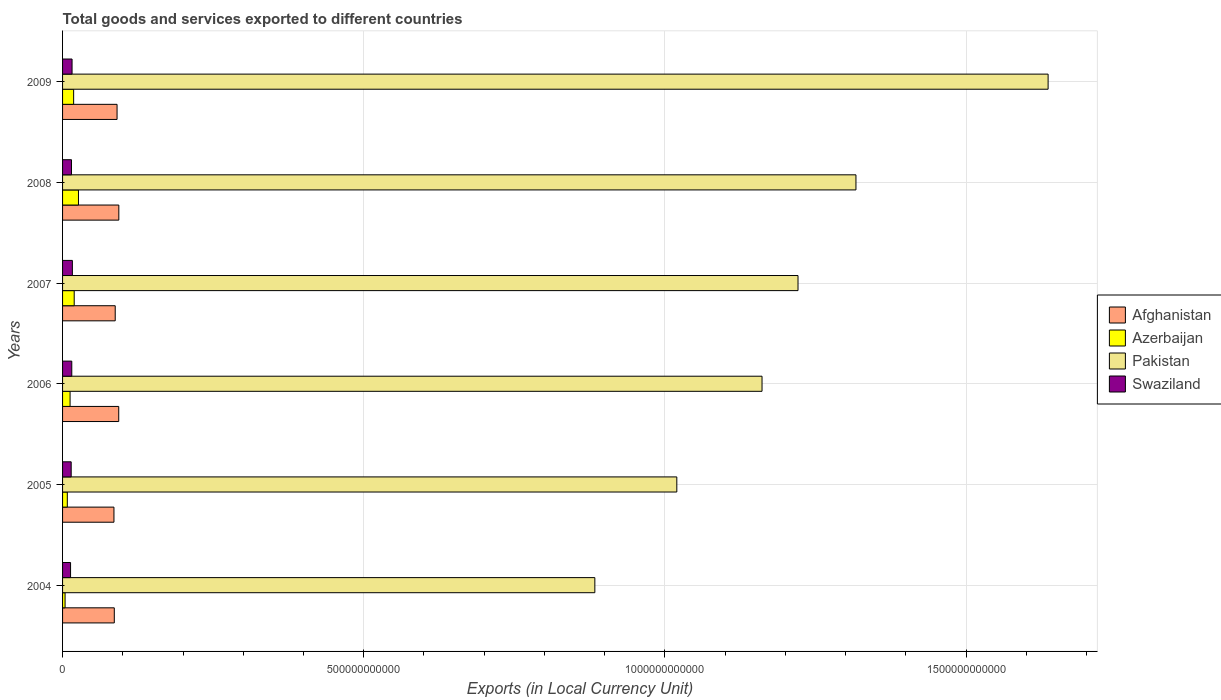What is the label of the 5th group of bars from the top?
Make the answer very short. 2005. What is the Amount of goods and services exports in Swaziland in 2008?
Offer a terse response. 1.48e+1. Across all years, what is the maximum Amount of goods and services exports in Afghanistan?
Offer a very short reply. 9.34e+1. Across all years, what is the minimum Amount of goods and services exports in Afghanistan?
Offer a terse response. 8.53e+1. In which year was the Amount of goods and services exports in Pakistan minimum?
Provide a short and direct response. 2004. What is the total Amount of goods and services exports in Pakistan in the graph?
Provide a short and direct response. 7.24e+12. What is the difference between the Amount of goods and services exports in Swaziland in 2004 and that in 2007?
Offer a very short reply. -3.00e+09. What is the difference between the Amount of goods and services exports in Azerbaijan in 2006 and the Amount of goods and services exports in Pakistan in 2009?
Your answer should be compact. -1.62e+12. What is the average Amount of goods and services exports in Pakistan per year?
Make the answer very short. 1.21e+12. In the year 2008, what is the difference between the Amount of goods and services exports in Azerbaijan and Amount of goods and services exports in Pakistan?
Make the answer very short. -1.29e+12. In how many years, is the Amount of goods and services exports in Pakistan greater than 1600000000000 LCU?
Offer a very short reply. 1. What is the ratio of the Amount of goods and services exports in Swaziland in 2007 to that in 2008?
Offer a terse response. 1.1. Is the Amount of goods and services exports in Pakistan in 2005 less than that in 2006?
Keep it short and to the point. Yes. What is the difference between the highest and the second highest Amount of goods and services exports in Swaziland?
Your response must be concise. 5.19e+08. What is the difference between the highest and the lowest Amount of goods and services exports in Swaziland?
Keep it short and to the point. 3.00e+09. In how many years, is the Amount of goods and services exports in Swaziland greater than the average Amount of goods and services exports in Swaziland taken over all years?
Provide a short and direct response. 3. Is it the case that in every year, the sum of the Amount of goods and services exports in Swaziland and Amount of goods and services exports in Azerbaijan is greater than the sum of Amount of goods and services exports in Afghanistan and Amount of goods and services exports in Pakistan?
Your response must be concise. No. What does the 3rd bar from the top in 2005 represents?
Keep it short and to the point. Azerbaijan. What does the 1st bar from the bottom in 2004 represents?
Your answer should be compact. Afghanistan. Is it the case that in every year, the sum of the Amount of goods and services exports in Azerbaijan and Amount of goods and services exports in Afghanistan is greater than the Amount of goods and services exports in Pakistan?
Give a very brief answer. No. Are all the bars in the graph horizontal?
Give a very brief answer. Yes. How many years are there in the graph?
Your answer should be very brief. 6. What is the difference between two consecutive major ticks on the X-axis?
Offer a terse response. 5.00e+11. Where does the legend appear in the graph?
Ensure brevity in your answer.  Center right. What is the title of the graph?
Give a very brief answer. Total goods and services exported to different countries. What is the label or title of the X-axis?
Your answer should be compact. Exports (in Local Currency Unit). What is the Exports (in Local Currency Unit) in Afghanistan in 2004?
Your answer should be compact. 8.59e+1. What is the Exports (in Local Currency Unit) in Azerbaijan in 2004?
Ensure brevity in your answer.  4.16e+09. What is the Exports (in Local Currency Unit) in Pakistan in 2004?
Offer a terse response. 8.84e+11. What is the Exports (in Local Currency Unit) in Swaziland in 2004?
Your answer should be very brief. 1.33e+1. What is the Exports (in Local Currency Unit) in Afghanistan in 2005?
Keep it short and to the point. 8.53e+1. What is the Exports (in Local Currency Unit) in Azerbaijan in 2005?
Make the answer very short. 7.88e+09. What is the Exports (in Local Currency Unit) of Pakistan in 2005?
Provide a succinct answer. 1.02e+12. What is the Exports (in Local Currency Unit) of Swaziland in 2005?
Ensure brevity in your answer.  1.43e+1. What is the Exports (in Local Currency Unit) in Afghanistan in 2006?
Keep it short and to the point. 9.33e+1. What is the Exports (in Local Currency Unit) of Azerbaijan in 2006?
Offer a terse response. 1.25e+1. What is the Exports (in Local Currency Unit) of Pakistan in 2006?
Your answer should be very brief. 1.16e+12. What is the Exports (in Local Currency Unit) of Swaziland in 2006?
Provide a succinct answer. 1.53e+1. What is the Exports (in Local Currency Unit) in Afghanistan in 2007?
Make the answer very short. 8.74e+1. What is the Exports (in Local Currency Unit) of Azerbaijan in 2007?
Give a very brief answer. 1.93e+1. What is the Exports (in Local Currency Unit) in Pakistan in 2007?
Provide a short and direct response. 1.22e+12. What is the Exports (in Local Currency Unit) of Swaziland in 2007?
Offer a terse response. 1.63e+1. What is the Exports (in Local Currency Unit) in Afghanistan in 2008?
Provide a succinct answer. 9.34e+1. What is the Exports (in Local Currency Unit) of Azerbaijan in 2008?
Keep it short and to the point. 2.64e+1. What is the Exports (in Local Currency Unit) in Pakistan in 2008?
Provide a short and direct response. 1.32e+12. What is the Exports (in Local Currency Unit) of Swaziland in 2008?
Provide a succinct answer. 1.48e+1. What is the Exports (in Local Currency Unit) in Afghanistan in 2009?
Give a very brief answer. 9.05e+1. What is the Exports (in Local Currency Unit) in Azerbaijan in 2009?
Give a very brief answer. 1.84e+1. What is the Exports (in Local Currency Unit) of Pakistan in 2009?
Offer a very short reply. 1.64e+12. What is the Exports (in Local Currency Unit) in Swaziland in 2009?
Your answer should be very brief. 1.58e+1. Across all years, what is the maximum Exports (in Local Currency Unit) in Afghanistan?
Offer a terse response. 9.34e+1. Across all years, what is the maximum Exports (in Local Currency Unit) of Azerbaijan?
Your answer should be compact. 2.64e+1. Across all years, what is the maximum Exports (in Local Currency Unit) in Pakistan?
Offer a very short reply. 1.64e+12. Across all years, what is the maximum Exports (in Local Currency Unit) in Swaziland?
Your answer should be very brief. 1.63e+1. Across all years, what is the minimum Exports (in Local Currency Unit) of Afghanistan?
Offer a terse response. 8.53e+1. Across all years, what is the minimum Exports (in Local Currency Unit) in Azerbaijan?
Provide a succinct answer. 4.16e+09. Across all years, what is the minimum Exports (in Local Currency Unit) of Pakistan?
Your response must be concise. 8.84e+11. Across all years, what is the minimum Exports (in Local Currency Unit) of Swaziland?
Give a very brief answer. 1.33e+1. What is the total Exports (in Local Currency Unit) in Afghanistan in the graph?
Your answer should be compact. 5.36e+11. What is the total Exports (in Local Currency Unit) of Azerbaijan in the graph?
Offer a very short reply. 8.86e+1. What is the total Exports (in Local Currency Unit) of Pakistan in the graph?
Provide a short and direct response. 7.24e+12. What is the total Exports (in Local Currency Unit) in Swaziland in the graph?
Your answer should be compact. 8.97e+1. What is the difference between the Exports (in Local Currency Unit) of Afghanistan in 2004 and that in 2005?
Offer a very short reply. 5.55e+08. What is the difference between the Exports (in Local Currency Unit) of Azerbaijan in 2004 and that in 2005?
Your answer should be compact. -3.72e+09. What is the difference between the Exports (in Local Currency Unit) of Pakistan in 2004 and that in 2005?
Your answer should be compact. -1.36e+11. What is the difference between the Exports (in Local Currency Unit) of Swaziland in 2004 and that in 2005?
Offer a terse response. -1.03e+09. What is the difference between the Exports (in Local Currency Unit) of Afghanistan in 2004 and that in 2006?
Provide a succinct answer. -7.38e+09. What is the difference between the Exports (in Local Currency Unit) of Azerbaijan in 2004 and that in 2006?
Your response must be concise. -8.31e+09. What is the difference between the Exports (in Local Currency Unit) in Pakistan in 2004 and that in 2006?
Your answer should be very brief. -2.78e+11. What is the difference between the Exports (in Local Currency Unit) of Swaziland in 2004 and that in 2006?
Make the answer very short. -2.01e+09. What is the difference between the Exports (in Local Currency Unit) in Afghanistan in 2004 and that in 2007?
Your response must be concise. -1.53e+09. What is the difference between the Exports (in Local Currency Unit) of Azerbaijan in 2004 and that in 2007?
Ensure brevity in your answer.  -1.52e+1. What is the difference between the Exports (in Local Currency Unit) of Pakistan in 2004 and that in 2007?
Your answer should be very brief. -3.37e+11. What is the difference between the Exports (in Local Currency Unit) in Swaziland in 2004 and that in 2007?
Your answer should be very brief. -3.00e+09. What is the difference between the Exports (in Local Currency Unit) of Afghanistan in 2004 and that in 2008?
Make the answer very short. -7.54e+09. What is the difference between the Exports (in Local Currency Unit) in Azerbaijan in 2004 and that in 2008?
Provide a succinct answer. -2.22e+1. What is the difference between the Exports (in Local Currency Unit) of Pakistan in 2004 and that in 2008?
Provide a succinct answer. -4.33e+11. What is the difference between the Exports (in Local Currency Unit) in Swaziland in 2004 and that in 2008?
Give a very brief answer. -1.53e+09. What is the difference between the Exports (in Local Currency Unit) of Afghanistan in 2004 and that in 2009?
Provide a short and direct response. -4.59e+09. What is the difference between the Exports (in Local Currency Unit) in Azerbaijan in 2004 and that in 2009?
Provide a succinct answer. -1.42e+1. What is the difference between the Exports (in Local Currency Unit) in Pakistan in 2004 and that in 2009?
Make the answer very short. -7.52e+11. What is the difference between the Exports (in Local Currency Unit) in Swaziland in 2004 and that in 2009?
Your answer should be very brief. -2.48e+09. What is the difference between the Exports (in Local Currency Unit) of Afghanistan in 2005 and that in 2006?
Keep it short and to the point. -7.94e+09. What is the difference between the Exports (in Local Currency Unit) in Azerbaijan in 2005 and that in 2006?
Ensure brevity in your answer.  -4.59e+09. What is the difference between the Exports (in Local Currency Unit) in Pakistan in 2005 and that in 2006?
Offer a terse response. -1.41e+11. What is the difference between the Exports (in Local Currency Unit) of Swaziland in 2005 and that in 2006?
Ensure brevity in your answer.  -9.86e+08. What is the difference between the Exports (in Local Currency Unit) of Afghanistan in 2005 and that in 2007?
Make the answer very short. -2.09e+09. What is the difference between the Exports (in Local Currency Unit) in Azerbaijan in 2005 and that in 2007?
Make the answer very short. -1.14e+1. What is the difference between the Exports (in Local Currency Unit) in Pakistan in 2005 and that in 2007?
Ensure brevity in your answer.  -2.01e+11. What is the difference between the Exports (in Local Currency Unit) of Swaziland in 2005 and that in 2007?
Ensure brevity in your answer.  -1.97e+09. What is the difference between the Exports (in Local Currency Unit) of Afghanistan in 2005 and that in 2008?
Your answer should be very brief. -8.10e+09. What is the difference between the Exports (in Local Currency Unit) of Azerbaijan in 2005 and that in 2008?
Keep it short and to the point. -1.85e+1. What is the difference between the Exports (in Local Currency Unit) of Pakistan in 2005 and that in 2008?
Your answer should be compact. -2.97e+11. What is the difference between the Exports (in Local Currency Unit) in Swaziland in 2005 and that in 2008?
Your answer should be very brief. -5.01e+08. What is the difference between the Exports (in Local Currency Unit) in Afghanistan in 2005 and that in 2009?
Your answer should be very brief. -5.15e+09. What is the difference between the Exports (in Local Currency Unit) in Azerbaijan in 2005 and that in 2009?
Provide a short and direct response. -1.05e+1. What is the difference between the Exports (in Local Currency Unit) in Pakistan in 2005 and that in 2009?
Provide a short and direct response. -6.16e+11. What is the difference between the Exports (in Local Currency Unit) in Swaziland in 2005 and that in 2009?
Provide a short and direct response. -1.45e+09. What is the difference between the Exports (in Local Currency Unit) in Afghanistan in 2006 and that in 2007?
Give a very brief answer. 5.85e+09. What is the difference between the Exports (in Local Currency Unit) in Azerbaijan in 2006 and that in 2007?
Give a very brief answer. -6.85e+09. What is the difference between the Exports (in Local Currency Unit) in Pakistan in 2006 and that in 2007?
Provide a short and direct response. -5.97e+1. What is the difference between the Exports (in Local Currency Unit) of Swaziland in 2006 and that in 2007?
Keep it short and to the point. -9.86e+08. What is the difference between the Exports (in Local Currency Unit) of Afghanistan in 2006 and that in 2008?
Your response must be concise. -1.60e+08. What is the difference between the Exports (in Local Currency Unit) in Azerbaijan in 2006 and that in 2008?
Give a very brief answer. -1.39e+1. What is the difference between the Exports (in Local Currency Unit) in Pakistan in 2006 and that in 2008?
Provide a short and direct response. -1.56e+11. What is the difference between the Exports (in Local Currency Unit) in Swaziland in 2006 and that in 2008?
Offer a terse response. 4.85e+08. What is the difference between the Exports (in Local Currency Unit) of Afghanistan in 2006 and that in 2009?
Give a very brief answer. 2.79e+09. What is the difference between the Exports (in Local Currency Unit) of Azerbaijan in 2006 and that in 2009?
Keep it short and to the point. -5.92e+09. What is the difference between the Exports (in Local Currency Unit) of Pakistan in 2006 and that in 2009?
Ensure brevity in your answer.  -4.75e+11. What is the difference between the Exports (in Local Currency Unit) in Swaziland in 2006 and that in 2009?
Give a very brief answer. -4.68e+08. What is the difference between the Exports (in Local Currency Unit) of Afghanistan in 2007 and that in 2008?
Your response must be concise. -6.01e+09. What is the difference between the Exports (in Local Currency Unit) of Azerbaijan in 2007 and that in 2008?
Your answer should be very brief. -7.08e+09. What is the difference between the Exports (in Local Currency Unit) of Pakistan in 2007 and that in 2008?
Your answer should be compact. -9.62e+1. What is the difference between the Exports (in Local Currency Unit) of Swaziland in 2007 and that in 2008?
Your response must be concise. 1.47e+09. What is the difference between the Exports (in Local Currency Unit) of Afghanistan in 2007 and that in 2009?
Your answer should be very brief. -3.06e+09. What is the difference between the Exports (in Local Currency Unit) in Azerbaijan in 2007 and that in 2009?
Provide a short and direct response. 9.39e+08. What is the difference between the Exports (in Local Currency Unit) of Pakistan in 2007 and that in 2009?
Provide a succinct answer. -4.15e+11. What is the difference between the Exports (in Local Currency Unit) in Swaziland in 2007 and that in 2009?
Ensure brevity in your answer.  5.19e+08. What is the difference between the Exports (in Local Currency Unit) in Afghanistan in 2008 and that in 2009?
Ensure brevity in your answer.  2.95e+09. What is the difference between the Exports (in Local Currency Unit) in Azerbaijan in 2008 and that in 2009?
Your response must be concise. 8.02e+09. What is the difference between the Exports (in Local Currency Unit) of Pakistan in 2008 and that in 2009?
Offer a terse response. -3.19e+11. What is the difference between the Exports (in Local Currency Unit) in Swaziland in 2008 and that in 2009?
Give a very brief answer. -9.53e+08. What is the difference between the Exports (in Local Currency Unit) of Afghanistan in 2004 and the Exports (in Local Currency Unit) of Azerbaijan in 2005?
Your answer should be compact. 7.80e+1. What is the difference between the Exports (in Local Currency Unit) of Afghanistan in 2004 and the Exports (in Local Currency Unit) of Pakistan in 2005?
Make the answer very short. -9.34e+11. What is the difference between the Exports (in Local Currency Unit) in Afghanistan in 2004 and the Exports (in Local Currency Unit) in Swaziland in 2005?
Provide a short and direct response. 7.16e+1. What is the difference between the Exports (in Local Currency Unit) in Azerbaijan in 2004 and the Exports (in Local Currency Unit) in Pakistan in 2005?
Provide a succinct answer. -1.02e+12. What is the difference between the Exports (in Local Currency Unit) of Azerbaijan in 2004 and the Exports (in Local Currency Unit) of Swaziland in 2005?
Ensure brevity in your answer.  -1.01e+1. What is the difference between the Exports (in Local Currency Unit) in Pakistan in 2004 and the Exports (in Local Currency Unit) in Swaziland in 2005?
Make the answer very short. 8.69e+11. What is the difference between the Exports (in Local Currency Unit) of Afghanistan in 2004 and the Exports (in Local Currency Unit) of Azerbaijan in 2006?
Your answer should be very brief. 7.34e+1. What is the difference between the Exports (in Local Currency Unit) of Afghanistan in 2004 and the Exports (in Local Currency Unit) of Pakistan in 2006?
Your answer should be compact. -1.08e+12. What is the difference between the Exports (in Local Currency Unit) in Afghanistan in 2004 and the Exports (in Local Currency Unit) in Swaziland in 2006?
Keep it short and to the point. 7.06e+1. What is the difference between the Exports (in Local Currency Unit) in Azerbaijan in 2004 and the Exports (in Local Currency Unit) in Pakistan in 2006?
Keep it short and to the point. -1.16e+12. What is the difference between the Exports (in Local Currency Unit) of Azerbaijan in 2004 and the Exports (in Local Currency Unit) of Swaziland in 2006?
Ensure brevity in your answer.  -1.11e+1. What is the difference between the Exports (in Local Currency Unit) of Pakistan in 2004 and the Exports (in Local Currency Unit) of Swaziland in 2006?
Offer a very short reply. 8.68e+11. What is the difference between the Exports (in Local Currency Unit) in Afghanistan in 2004 and the Exports (in Local Currency Unit) in Azerbaijan in 2007?
Give a very brief answer. 6.66e+1. What is the difference between the Exports (in Local Currency Unit) in Afghanistan in 2004 and the Exports (in Local Currency Unit) in Pakistan in 2007?
Your answer should be very brief. -1.14e+12. What is the difference between the Exports (in Local Currency Unit) in Afghanistan in 2004 and the Exports (in Local Currency Unit) in Swaziland in 2007?
Provide a succinct answer. 6.96e+1. What is the difference between the Exports (in Local Currency Unit) in Azerbaijan in 2004 and the Exports (in Local Currency Unit) in Pakistan in 2007?
Your response must be concise. -1.22e+12. What is the difference between the Exports (in Local Currency Unit) in Azerbaijan in 2004 and the Exports (in Local Currency Unit) in Swaziland in 2007?
Provide a succinct answer. -1.21e+1. What is the difference between the Exports (in Local Currency Unit) of Pakistan in 2004 and the Exports (in Local Currency Unit) of Swaziland in 2007?
Provide a short and direct response. 8.67e+11. What is the difference between the Exports (in Local Currency Unit) in Afghanistan in 2004 and the Exports (in Local Currency Unit) in Azerbaijan in 2008?
Your answer should be very brief. 5.95e+1. What is the difference between the Exports (in Local Currency Unit) in Afghanistan in 2004 and the Exports (in Local Currency Unit) in Pakistan in 2008?
Offer a terse response. -1.23e+12. What is the difference between the Exports (in Local Currency Unit) of Afghanistan in 2004 and the Exports (in Local Currency Unit) of Swaziland in 2008?
Your answer should be very brief. 7.11e+1. What is the difference between the Exports (in Local Currency Unit) of Azerbaijan in 2004 and the Exports (in Local Currency Unit) of Pakistan in 2008?
Offer a terse response. -1.31e+12. What is the difference between the Exports (in Local Currency Unit) of Azerbaijan in 2004 and the Exports (in Local Currency Unit) of Swaziland in 2008?
Your response must be concise. -1.06e+1. What is the difference between the Exports (in Local Currency Unit) of Pakistan in 2004 and the Exports (in Local Currency Unit) of Swaziland in 2008?
Provide a succinct answer. 8.69e+11. What is the difference between the Exports (in Local Currency Unit) in Afghanistan in 2004 and the Exports (in Local Currency Unit) in Azerbaijan in 2009?
Your answer should be compact. 6.75e+1. What is the difference between the Exports (in Local Currency Unit) in Afghanistan in 2004 and the Exports (in Local Currency Unit) in Pakistan in 2009?
Offer a terse response. -1.55e+12. What is the difference between the Exports (in Local Currency Unit) in Afghanistan in 2004 and the Exports (in Local Currency Unit) in Swaziland in 2009?
Provide a short and direct response. 7.01e+1. What is the difference between the Exports (in Local Currency Unit) of Azerbaijan in 2004 and the Exports (in Local Currency Unit) of Pakistan in 2009?
Keep it short and to the point. -1.63e+12. What is the difference between the Exports (in Local Currency Unit) of Azerbaijan in 2004 and the Exports (in Local Currency Unit) of Swaziland in 2009?
Offer a very short reply. -1.16e+1. What is the difference between the Exports (in Local Currency Unit) in Pakistan in 2004 and the Exports (in Local Currency Unit) in Swaziland in 2009?
Your response must be concise. 8.68e+11. What is the difference between the Exports (in Local Currency Unit) in Afghanistan in 2005 and the Exports (in Local Currency Unit) in Azerbaijan in 2006?
Provide a succinct answer. 7.29e+1. What is the difference between the Exports (in Local Currency Unit) of Afghanistan in 2005 and the Exports (in Local Currency Unit) of Pakistan in 2006?
Make the answer very short. -1.08e+12. What is the difference between the Exports (in Local Currency Unit) in Afghanistan in 2005 and the Exports (in Local Currency Unit) in Swaziland in 2006?
Make the answer very short. 7.00e+1. What is the difference between the Exports (in Local Currency Unit) in Azerbaijan in 2005 and the Exports (in Local Currency Unit) in Pakistan in 2006?
Your response must be concise. -1.15e+12. What is the difference between the Exports (in Local Currency Unit) in Azerbaijan in 2005 and the Exports (in Local Currency Unit) in Swaziland in 2006?
Provide a succinct answer. -7.41e+09. What is the difference between the Exports (in Local Currency Unit) of Pakistan in 2005 and the Exports (in Local Currency Unit) of Swaziland in 2006?
Provide a short and direct response. 1.00e+12. What is the difference between the Exports (in Local Currency Unit) of Afghanistan in 2005 and the Exports (in Local Currency Unit) of Azerbaijan in 2007?
Your answer should be compact. 6.60e+1. What is the difference between the Exports (in Local Currency Unit) in Afghanistan in 2005 and the Exports (in Local Currency Unit) in Pakistan in 2007?
Your answer should be compact. -1.14e+12. What is the difference between the Exports (in Local Currency Unit) in Afghanistan in 2005 and the Exports (in Local Currency Unit) in Swaziland in 2007?
Make the answer very short. 6.90e+1. What is the difference between the Exports (in Local Currency Unit) in Azerbaijan in 2005 and the Exports (in Local Currency Unit) in Pakistan in 2007?
Offer a very short reply. -1.21e+12. What is the difference between the Exports (in Local Currency Unit) in Azerbaijan in 2005 and the Exports (in Local Currency Unit) in Swaziland in 2007?
Give a very brief answer. -8.40e+09. What is the difference between the Exports (in Local Currency Unit) in Pakistan in 2005 and the Exports (in Local Currency Unit) in Swaziland in 2007?
Your answer should be compact. 1.00e+12. What is the difference between the Exports (in Local Currency Unit) of Afghanistan in 2005 and the Exports (in Local Currency Unit) of Azerbaijan in 2008?
Your response must be concise. 5.89e+1. What is the difference between the Exports (in Local Currency Unit) in Afghanistan in 2005 and the Exports (in Local Currency Unit) in Pakistan in 2008?
Offer a very short reply. -1.23e+12. What is the difference between the Exports (in Local Currency Unit) in Afghanistan in 2005 and the Exports (in Local Currency Unit) in Swaziland in 2008?
Keep it short and to the point. 7.05e+1. What is the difference between the Exports (in Local Currency Unit) in Azerbaijan in 2005 and the Exports (in Local Currency Unit) in Pakistan in 2008?
Make the answer very short. -1.31e+12. What is the difference between the Exports (in Local Currency Unit) in Azerbaijan in 2005 and the Exports (in Local Currency Unit) in Swaziland in 2008?
Offer a very short reply. -6.93e+09. What is the difference between the Exports (in Local Currency Unit) in Pakistan in 2005 and the Exports (in Local Currency Unit) in Swaziland in 2008?
Your answer should be very brief. 1.00e+12. What is the difference between the Exports (in Local Currency Unit) of Afghanistan in 2005 and the Exports (in Local Currency Unit) of Azerbaijan in 2009?
Make the answer very short. 6.69e+1. What is the difference between the Exports (in Local Currency Unit) in Afghanistan in 2005 and the Exports (in Local Currency Unit) in Pakistan in 2009?
Provide a short and direct response. -1.55e+12. What is the difference between the Exports (in Local Currency Unit) in Afghanistan in 2005 and the Exports (in Local Currency Unit) in Swaziland in 2009?
Keep it short and to the point. 6.96e+1. What is the difference between the Exports (in Local Currency Unit) in Azerbaijan in 2005 and the Exports (in Local Currency Unit) in Pakistan in 2009?
Offer a very short reply. -1.63e+12. What is the difference between the Exports (in Local Currency Unit) in Azerbaijan in 2005 and the Exports (in Local Currency Unit) in Swaziland in 2009?
Offer a very short reply. -7.88e+09. What is the difference between the Exports (in Local Currency Unit) in Pakistan in 2005 and the Exports (in Local Currency Unit) in Swaziland in 2009?
Offer a terse response. 1.00e+12. What is the difference between the Exports (in Local Currency Unit) in Afghanistan in 2006 and the Exports (in Local Currency Unit) in Azerbaijan in 2007?
Your response must be concise. 7.39e+1. What is the difference between the Exports (in Local Currency Unit) in Afghanistan in 2006 and the Exports (in Local Currency Unit) in Pakistan in 2007?
Your answer should be compact. -1.13e+12. What is the difference between the Exports (in Local Currency Unit) of Afghanistan in 2006 and the Exports (in Local Currency Unit) of Swaziland in 2007?
Your answer should be very brief. 7.70e+1. What is the difference between the Exports (in Local Currency Unit) in Azerbaijan in 2006 and the Exports (in Local Currency Unit) in Pakistan in 2007?
Offer a terse response. -1.21e+12. What is the difference between the Exports (in Local Currency Unit) in Azerbaijan in 2006 and the Exports (in Local Currency Unit) in Swaziland in 2007?
Ensure brevity in your answer.  -3.81e+09. What is the difference between the Exports (in Local Currency Unit) of Pakistan in 2006 and the Exports (in Local Currency Unit) of Swaziland in 2007?
Give a very brief answer. 1.14e+12. What is the difference between the Exports (in Local Currency Unit) in Afghanistan in 2006 and the Exports (in Local Currency Unit) in Azerbaijan in 2008?
Keep it short and to the point. 6.69e+1. What is the difference between the Exports (in Local Currency Unit) in Afghanistan in 2006 and the Exports (in Local Currency Unit) in Pakistan in 2008?
Keep it short and to the point. -1.22e+12. What is the difference between the Exports (in Local Currency Unit) in Afghanistan in 2006 and the Exports (in Local Currency Unit) in Swaziland in 2008?
Give a very brief answer. 7.84e+1. What is the difference between the Exports (in Local Currency Unit) in Azerbaijan in 2006 and the Exports (in Local Currency Unit) in Pakistan in 2008?
Your answer should be compact. -1.30e+12. What is the difference between the Exports (in Local Currency Unit) of Azerbaijan in 2006 and the Exports (in Local Currency Unit) of Swaziland in 2008?
Make the answer very short. -2.34e+09. What is the difference between the Exports (in Local Currency Unit) in Pakistan in 2006 and the Exports (in Local Currency Unit) in Swaziland in 2008?
Give a very brief answer. 1.15e+12. What is the difference between the Exports (in Local Currency Unit) of Afghanistan in 2006 and the Exports (in Local Currency Unit) of Azerbaijan in 2009?
Your response must be concise. 7.49e+1. What is the difference between the Exports (in Local Currency Unit) in Afghanistan in 2006 and the Exports (in Local Currency Unit) in Pakistan in 2009?
Provide a succinct answer. -1.54e+12. What is the difference between the Exports (in Local Currency Unit) in Afghanistan in 2006 and the Exports (in Local Currency Unit) in Swaziland in 2009?
Provide a succinct answer. 7.75e+1. What is the difference between the Exports (in Local Currency Unit) of Azerbaijan in 2006 and the Exports (in Local Currency Unit) of Pakistan in 2009?
Keep it short and to the point. -1.62e+12. What is the difference between the Exports (in Local Currency Unit) in Azerbaijan in 2006 and the Exports (in Local Currency Unit) in Swaziland in 2009?
Your answer should be very brief. -3.29e+09. What is the difference between the Exports (in Local Currency Unit) in Pakistan in 2006 and the Exports (in Local Currency Unit) in Swaziland in 2009?
Ensure brevity in your answer.  1.15e+12. What is the difference between the Exports (in Local Currency Unit) in Afghanistan in 2007 and the Exports (in Local Currency Unit) in Azerbaijan in 2008?
Make the answer very short. 6.10e+1. What is the difference between the Exports (in Local Currency Unit) of Afghanistan in 2007 and the Exports (in Local Currency Unit) of Pakistan in 2008?
Your answer should be very brief. -1.23e+12. What is the difference between the Exports (in Local Currency Unit) of Afghanistan in 2007 and the Exports (in Local Currency Unit) of Swaziland in 2008?
Provide a short and direct response. 7.26e+1. What is the difference between the Exports (in Local Currency Unit) of Azerbaijan in 2007 and the Exports (in Local Currency Unit) of Pakistan in 2008?
Ensure brevity in your answer.  -1.30e+12. What is the difference between the Exports (in Local Currency Unit) of Azerbaijan in 2007 and the Exports (in Local Currency Unit) of Swaziland in 2008?
Give a very brief answer. 4.51e+09. What is the difference between the Exports (in Local Currency Unit) in Pakistan in 2007 and the Exports (in Local Currency Unit) in Swaziland in 2008?
Keep it short and to the point. 1.21e+12. What is the difference between the Exports (in Local Currency Unit) in Afghanistan in 2007 and the Exports (in Local Currency Unit) in Azerbaijan in 2009?
Your answer should be very brief. 6.90e+1. What is the difference between the Exports (in Local Currency Unit) in Afghanistan in 2007 and the Exports (in Local Currency Unit) in Pakistan in 2009?
Give a very brief answer. -1.55e+12. What is the difference between the Exports (in Local Currency Unit) in Afghanistan in 2007 and the Exports (in Local Currency Unit) in Swaziland in 2009?
Your answer should be compact. 7.16e+1. What is the difference between the Exports (in Local Currency Unit) in Azerbaijan in 2007 and the Exports (in Local Currency Unit) in Pakistan in 2009?
Your answer should be very brief. -1.62e+12. What is the difference between the Exports (in Local Currency Unit) of Azerbaijan in 2007 and the Exports (in Local Currency Unit) of Swaziland in 2009?
Offer a very short reply. 3.56e+09. What is the difference between the Exports (in Local Currency Unit) of Pakistan in 2007 and the Exports (in Local Currency Unit) of Swaziland in 2009?
Offer a terse response. 1.21e+12. What is the difference between the Exports (in Local Currency Unit) in Afghanistan in 2008 and the Exports (in Local Currency Unit) in Azerbaijan in 2009?
Ensure brevity in your answer.  7.50e+1. What is the difference between the Exports (in Local Currency Unit) in Afghanistan in 2008 and the Exports (in Local Currency Unit) in Pakistan in 2009?
Provide a succinct answer. -1.54e+12. What is the difference between the Exports (in Local Currency Unit) in Afghanistan in 2008 and the Exports (in Local Currency Unit) in Swaziland in 2009?
Keep it short and to the point. 7.77e+1. What is the difference between the Exports (in Local Currency Unit) in Azerbaijan in 2008 and the Exports (in Local Currency Unit) in Pakistan in 2009?
Ensure brevity in your answer.  -1.61e+12. What is the difference between the Exports (in Local Currency Unit) of Azerbaijan in 2008 and the Exports (in Local Currency Unit) of Swaziland in 2009?
Your answer should be compact. 1.06e+1. What is the difference between the Exports (in Local Currency Unit) in Pakistan in 2008 and the Exports (in Local Currency Unit) in Swaziland in 2009?
Your response must be concise. 1.30e+12. What is the average Exports (in Local Currency Unit) of Afghanistan per year?
Give a very brief answer. 8.93e+1. What is the average Exports (in Local Currency Unit) of Azerbaijan per year?
Make the answer very short. 1.48e+1. What is the average Exports (in Local Currency Unit) in Pakistan per year?
Keep it short and to the point. 1.21e+12. What is the average Exports (in Local Currency Unit) in Swaziland per year?
Give a very brief answer. 1.50e+1. In the year 2004, what is the difference between the Exports (in Local Currency Unit) of Afghanistan and Exports (in Local Currency Unit) of Azerbaijan?
Your response must be concise. 8.17e+1. In the year 2004, what is the difference between the Exports (in Local Currency Unit) in Afghanistan and Exports (in Local Currency Unit) in Pakistan?
Offer a terse response. -7.98e+11. In the year 2004, what is the difference between the Exports (in Local Currency Unit) of Afghanistan and Exports (in Local Currency Unit) of Swaziland?
Give a very brief answer. 7.26e+1. In the year 2004, what is the difference between the Exports (in Local Currency Unit) of Azerbaijan and Exports (in Local Currency Unit) of Pakistan?
Offer a very short reply. -8.80e+11. In the year 2004, what is the difference between the Exports (in Local Currency Unit) of Azerbaijan and Exports (in Local Currency Unit) of Swaziland?
Provide a short and direct response. -9.12e+09. In the year 2004, what is the difference between the Exports (in Local Currency Unit) of Pakistan and Exports (in Local Currency Unit) of Swaziland?
Offer a very short reply. 8.70e+11. In the year 2005, what is the difference between the Exports (in Local Currency Unit) of Afghanistan and Exports (in Local Currency Unit) of Azerbaijan?
Give a very brief answer. 7.74e+1. In the year 2005, what is the difference between the Exports (in Local Currency Unit) in Afghanistan and Exports (in Local Currency Unit) in Pakistan?
Offer a terse response. -9.34e+11. In the year 2005, what is the difference between the Exports (in Local Currency Unit) in Afghanistan and Exports (in Local Currency Unit) in Swaziland?
Make the answer very short. 7.10e+1. In the year 2005, what is the difference between the Exports (in Local Currency Unit) of Azerbaijan and Exports (in Local Currency Unit) of Pakistan?
Provide a succinct answer. -1.01e+12. In the year 2005, what is the difference between the Exports (in Local Currency Unit) in Azerbaijan and Exports (in Local Currency Unit) in Swaziland?
Give a very brief answer. -6.43e+09. In the year 2005, what is the difference between the Exports (in Local Currency Unit) of Pakistan and Exports (in Local Currency Unit) of Swaziland?
Your answer should be very brief. 1.01e+12. In the year 2006, what is the difference between the Exports (in Local Currency Unit) in Afghanistan and Exports (in Local Currency Unit) in Azerbaijan?
Your response must be concise. 8.08e+1. In the year 2006, what is the difference between the Exports (in Local Currency Unit) of Afghanistan and Exports (in Local Currency Unit) of Pakistan?
Give a very brief answer. -1.07e+12. In the year 2006, what is the difference between the Exports (in Local Currency Unit) in Afghanistan and Exports (in Local Currency Unit) in Swaziland?
Give a very brief answer. 7.80e+1. In the year 2006, what is the difference between the Exports (in Local Currency Unit) of Azerbaijan and Exports (in Local Currency Unit) of Pakistan?
Provide a short and direct response. -1.15e+12. In the year 2006, what is the difference between the Exports (in Local Currency Unit) of Azerbaijan and Exports (in Local Currency Unit) of Swaziland?
Give a very brief answer. -2.83e+09. In the year 2006, what is the difference between the Exports (in Local Currency Unit) of Pakistan and Exports (in Local Currency Unit) of Swaziland?
Keep it short and to the point. 1.15e+12. In the year 2007, what is the difference between the Exports (in Local Currency Unit) of Afghanistan and Exports (in Local Currency Unit) of Azerbaijan?
Offer a terse response. 6.81e+1. In the year 2007, what is the difference between the Exports (in Local Currency Unit) in Afghanistan and Exports (in Local Currency Unit) in Pakistan?
Your answer should be very brief. -1.13e+12. In the year 2007, what is the difference between the Exports (in Local Currency Unit) of Afghanistan and Exports (in Local Currency Unit) of Swaziland?
Ensure brevity in your answer.  7.11e+1. In the year 2007, what is the difference between the Exports (in Local Currency Unit) of Azerbaijan and Exports (in Local Currency Unit) of Pakistan?
Offer a terse response. -1.20e+12. In the year 2007, what is the difference between the Exports (in Local Currency Unit) in Azerbaijan and Exports (in Local Currency Unit) in Swaziland?
Provide a succinct answer. 3.04e+09. In the year 2007, what is the difference between the Exports (in Local Currency Unit) in Pakistan and Exports (in Local Currency Unit) in Swaziland?
Your answer should be compact. 1.20e+12. In the year 2008, what is the difference between the Exports (in Local Currency Unit) in Afghanistan and Exports (in Local Currency Unit) in Azerbaijan?
Ensure brevity in your answer.  6.70e+1. In the year 2008, what is the difference between the Exports (in Local Currency Unit) of Afghanistan and Exports (in Local Currency Unit) of Pakistan?
Your response must be concise. -1.22e+12. In the year 2008, what is the difference between the Exports (in Local Currency Unit) of Afghanistan and Exports (in Local Currency Unit) of Swaziland?
Your response must be concise. 7.86e+1. In the year 2008, what is the difference between the Exports (in Local Currency Unit) in Azerbaijan and Exports (in Local Currency Unit) in Pakistan?
Your answer should be very brief. -1.29e+12. In the year 2008, what is the difference between the Exports (in Local Currency Unit) in Azerbaijan and Exports (in Local Currency Unit) in Swaziland?
Your response must be concise. 1.16e+1. In the year 2008, what is the difference between the Exports (in Local Currency Unit) of Pakistan and Exports (in Local Currency Unit) of Swaziland?
Make the answer very short. 1.30e+12. In the year 2009, what is the difference between the Exports (in Local Currency Unit) of Afghanistan and Exports (in Local Currency Unit) of Azerbaijan?
Offer a terse response. 7.21e+1. In the year 2009, what is the difference between the Exports (in Local Currency Unit) in Afghanistan and Exports (in Local Currency Unit) in Pakistan?
Provide a short and direct response. -1.55e+12. In the year 2009, what is the difference between the Exports (in Local Currency Unit) of Afghanistan and Exports (in Local Currency Unit) of Swaziland?
Offer a very short reply. 7.47e+1. In the year 2009, what is the difference between the Exports (in Local Currency Unit) in Azerbaijan and Exports (in Local Currency Unit) in Pakistan?
Offer a terse response. -1.62e+12. In the year 2009, what is the difference between the Exports (in Local Currency Unit) in Azerbaijan and Exports (in Local Currency Unit) in Swaziland?
Provide a succinct answer. 2.62e+09. In the year 2009, what is the difference between the Exports (in Local Currency Unit) of Pakistan and Exports (in Local Currency Unit) of Swaziland?
Your response must be concise. 1.62e+12. What is the ratio of the Exports (in Local Currency Unit) in Azerbaijan in 2004 to that in 2005?
Your answer should be very brief. 0.53. What is the ratio of the Exports (in Local Currency Unit) of Pakistan in 2004 to that in 2005?
Offer a terse response. 0.87. What is the ratio of the Exports (in Local Currency Unit) of Swaziland in 2004 to that in 2005?
Give a very brief answer. 0.93. What is the ratio of the Exports (in Local Currency Unit) of Afghanistan in 2004 to that in 2006?
Offer a terse response. 0.92. What is the ratio of the Exports (in Local Currency Unit) of Azerbaijan in 2004 to that in 2006?
Give a very brief answer. 0.33. What is the ratio of the Exports (in Local Currency Unit) of Pakistan in 2004 to that in 2006?
Your response must be concise. 0.76. What is the ratio of the Exports (in Local Currency Unit) in Swaziland in 2004 to that in 2006?
Your answer should be compact. 0.87. What is the ratio of the Exports (in Local Currency Unit) in Afghanistan in 2004 to that in 2007?
Your answer should be very brief. 0.98. What is the ratio of the Exports (in Local Currency Unit) in Azerbaijan in 2004 to that in 2007?
Your answer should be compact. 0.22. What is the ratio of the Exports (in Local Currency Unit) of Pakistan in 2004 to that in 2007?
Provide a succinct answer. 0.72. What is the ratio of the Exports (in Local Currency Unit) in Swaziland in 2004 to that in 2007?
Offer a terse response. 0.82. What is the ratio of the Exports (in Local Currency Unit) in Afghanistan in 2004 to that in 2008?
Your answer should be compact. 0.92. What is the ratio of the Exports (in Local Currency Unit) in Azerbaijan in 2004 to that in 2008?
Provide a short and direct response. 0.16. What is the ratio of the Exports (in Local Currency Unit) of Pakistan in 2004 to that in 2008?
Offer a terse response. 0.67. What is the ratio of the Exports (in Local Currency Unit) in Swaziland in 2004 to that in 2008?
Make the answer very short. 0.9. What is the ratio of the Exports (in Local Currency Unit) of Afghanistan in 2004 to that in 2009?
Your answer should be compact. 0.95. What is the ratio of the Exports (in Local Currency Unit) in Azerbaijan in 2004 to that in 2009?
Your answer should be very brief. 0.23. What is the ratio of the Exports (in Local Currency Unit) in Pakistan in 2004 to that in 2009?
Your response must be concise. 0.54. What is the ratio of the Exports (in Local Currency Unit) of Swaziland in 2004 to that in 2009?
Your response must be concise. 0.84. What is the ratio of the Exports (in Local Currency Unit) in Afghanistan in 2005 to that in 2006?
Make the answer very short. 0.91. What is the ratio of the Exports (in Local Currency Unit) in Azerbaijan in 2005 to that in 2006?
Provide a short and direct response. 0.63. What is the ratio of the Exports (in Local Currency Unit) of Pakistan in 2005 to that in 2006?
Make the answer very short. 0.88. What is the ratio of the Exports (in Local Currency Unit) of Swaziland in 2005 to that in 2006?
Keep it short and to the point. 0.94. What is the ratio of the Exports (in Local Currency Unit) in Afghanistan in 2005 to that in 2007?
Provide a short and direct response. 0.98. What is the ratio of the Exports (in Local Currency Unit) of Azerbaijan in 2005 to that in 2007?
Provide a short and direct response. 0.41. What is the ratio of the Exports (in Local Currency Unit) of Pakistan in 2005 to that in 2007?
Offer a very short reply. 0.84. What is the ratio of the Exports (in Local Currency Unit) of Swaziland in 2005 to that in 2007?
Provide a short and direct response. 0.88. What is the ratio of the Exports (in Local Currency Unit) of Afghanistan in 2005 to that in 2008?
Give a very brief answer. 0.91. What is the ratio of the Exports (in Local Currency Unit) in Azerbaijan in 2005 to that in 2008?
Offer a very short reply. 0.3. What is the ratio of the Exports (in Local Currency Unit) of Pakistan in 2005 to that in 2008?
Keep it short and to the point. 0.77. What is the ratio of the Exports (in Local Currency Unit) of Swaziland in 2005 to that in 2008?
Provide a short and direct response. 0.97. What is the ratio of the Exports (in Local Currency Unit) in Afghanistan in 2005 to that in 2009?
Your answer should be very brief. 0.94. What is the ratio of the Exports (in Local Currency Unit) of Azerbaijan in 2005 to that in 2009?
Offer a terse response. 0.43. What is the ratio of the Exports (in Local Currency Unit) of Pakistan in 2005 to that in 2009?
Offer a very short reply. 0.62. What is the ratio of the Exports (in Local Currency Unit) in Swaziland in 2005 to that in 2009?
Provide a short and direct response. 0.91. What is the ratio of the Exports (in Local Currency Unit) in Afghanistan in 2006 to that in 2007?
Your answer should be compact. 1.07. What is the ratio of the Exports (in Local Currency Unit) of Azerbaijan in 2006 to that in 2007?
Offer a very short reply. 0.65. What is the ratio of the Exports (in Local Currency Unit) in Pakistan in 2006 to that in 2007?
Provide a short and direct response. 0.95. What is the ratio of the Exports (in Local Currency Unit) in Swaziland in 2006 to that in 2007?
Ensure brevity in your answer.  0.94. What is the ratio of the Exports (in Local Currency Unit) of Azerbaijan in 2006 to that in 2008?
Give a very brief answer. 0.47. What is the ratio of the Exports (in Local Currency Unit) of Pakistan in 2006 to that in 2008?
Provide a short and direct response. 0.88. What is the ratio of the Exports (in Local Currency Unit) of Swaziland in 2006 to that in 2008?
Offer a terse response. 1.03. What is the ratio of the Exports (in Local Currency Unit) in Afghanistan in 2006 to that in 2009?
Ensure brevity in your answer.  1.03. What is the ratio of the Exports (in Local Currency Unit) in Azerbaijan in 2006 to that in 2009?
Make the answer very short. 0.68. What is the ratio of the Exports (in Local Currency Unit) of Pakistan in 2006 to that in 2009?
Make the answer very short. 0.71. What is the ratio of the Exports (in Local Currency Unit) of Swaziland in 2006 to that in 2009?
Make the answer very short. 0.97. What is the ratio of the Exports (in Local Currency Unit) of Afghanistan in 2007 to that in 2008?
Offer a terse response. 0.94. What is the ratio of the Exports (in Local Currency Unit) of Azerbaijan in 2007 to that in 2008?
Provide a succinct answer. 0.73. What is the ratio of the Exports (in Local Currency Unit) of Pakistan in 2007 to that in 2008?
Provide a succinct answer. 0.93. What is the ratio of the Exports (in Local Currency Unit) of Swaziland in 2007 to that in 2008?
Your answer should be compact. 1.1. What is the ratio of the Exports (in Local Currency Unit) in Afghanistan in 2007 to that in 2009?
Offer a terse response. 0.97. What is the ratio of the Exports (in Local Currency Unit) of Azerbaijan in 2007 to that in 2009?
Keep it short and to the point. 1.05. What is the ratio of the Exports (in Local Currency Unit) in Pakistan in 2007 to that in 2009?
Your answer should be very brief. 0.75. What is the ratio of the Exports (in Local Currency Unit) in Swaziland in 2007 to that in 2009?
Offer a terse response. 1.03. What is the ratio of the Exports (in Local Currency Unit) of Afghanistan in 2008 to that in 2009?
Your response must be concise. 1.03. What is the ratio of the Exports (in Local Currency Unit) in Azerbaijan in 2008 to that in 2009?
Provide a short and direct response. 1.44. What is the ratio of the Exports (in Local Currency Unit) in Pakistan in 2008 to that in 2009?
Provide a succinct answer. 0.81. What is the ratio of the Exports (in Local Currency Unit) in Swaziland in 2008 to that in 2009?
Your response must be concise. 0.94. What is the difference between the highest and the second highest Exports (in Local Currency Unit) in Afghanistan?
Provide a succinct answer. 1.60e+08. What is the difference between the highest and the second highest Exports (in Local Currency Unit) of Azerbaijan?
Keep it short and to the point. 7.08e+09. What is the difference between the highest and the second highest Exports (in Local Currency Unit) of Pakistan?
Give a very brief answer. 3.19e+11. What is the difference between the highest and the second highest Exports (in Local Currency Unit) in Swaziland?
Ensure brevity in your answer.  5.19e+08. What is the difference between the highest and the lowest Exports (in Local Currency Unit) of Afghanistan?
Offer a terse response. 8.10e+09. What is the difference between the highest and the lowest Exports (in Local Currency Unit) in Azerbaijan?
Your response must be concise. 2.22e+1. What is the difference between the highest and the lowest Exports (in Local Currency Unit) in Pakistan?
Offer a terse response. 7.52e+11. What is the difference between the highest and the lowest Exports (in Local Currency Unit) in Swaziland?
Offer a very short reply. 3.00e+09. 